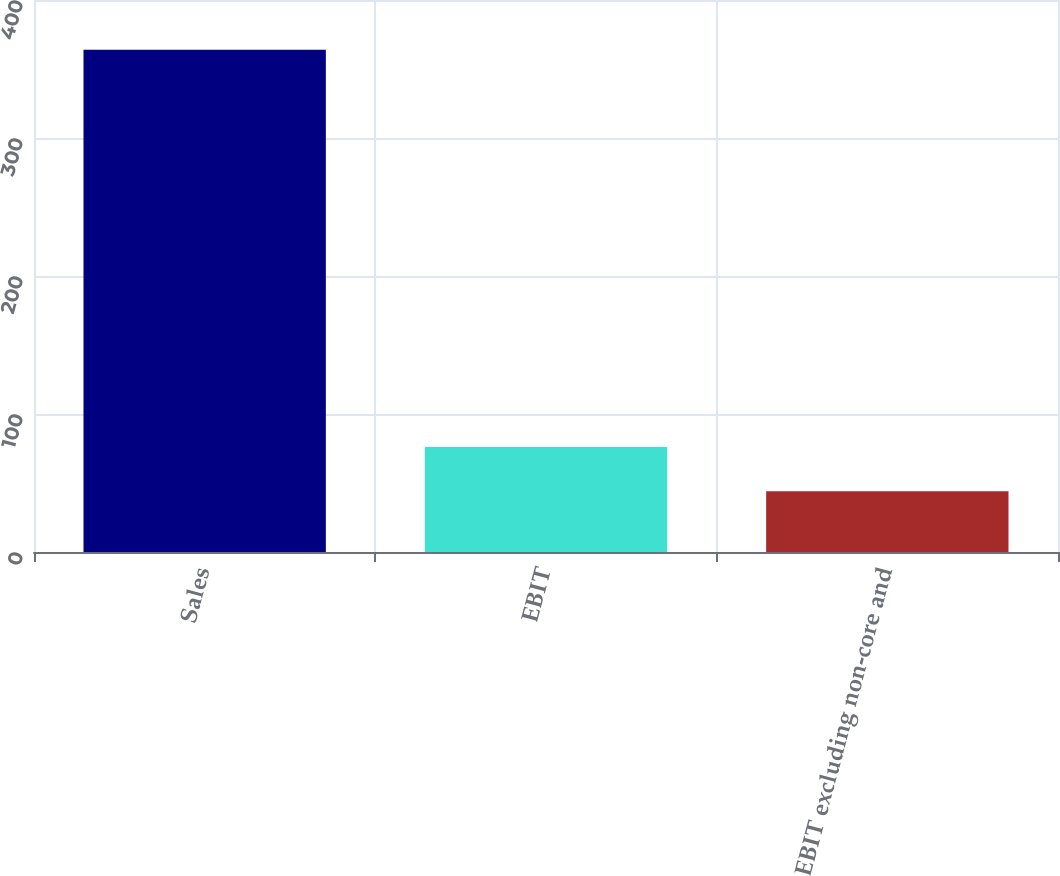Convert chart. <chart><loc_0><loc_0><loc_500><loc_500><bar_chart><fcel>Sales<fcel>EBIT<fcel>EBIT excluding non-core and<nl><fcel>364<fcel>76<fcel>44<nl></chart> 